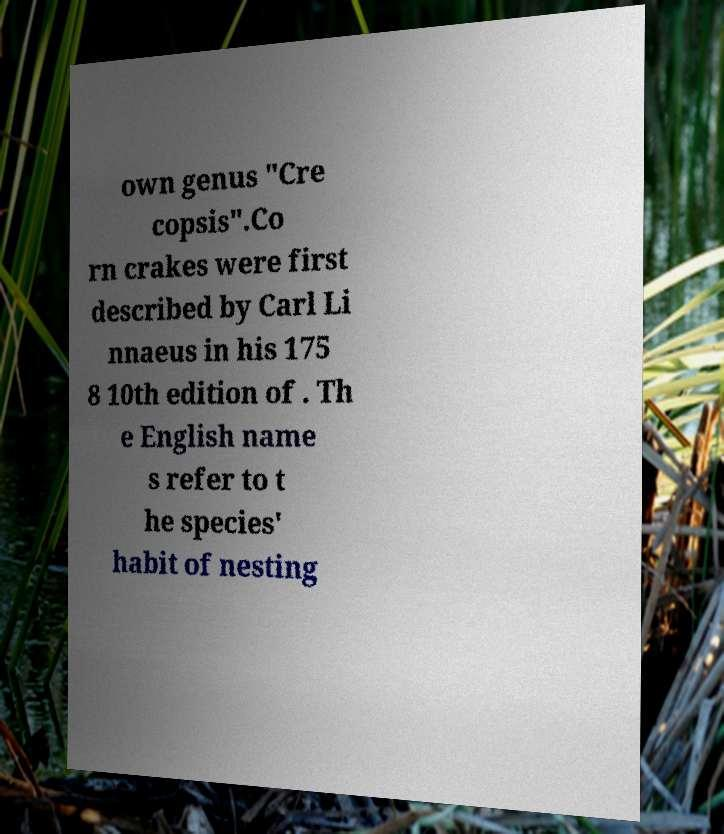For documentation purposes, I need the text within this image transcribed. Could you provide that? own genus "Cre copsis".Co rn crakes were first described by Carl Li nnaeus in his 175 8 10th edition of . Th e English name s refer to t he species' habit of nesting 